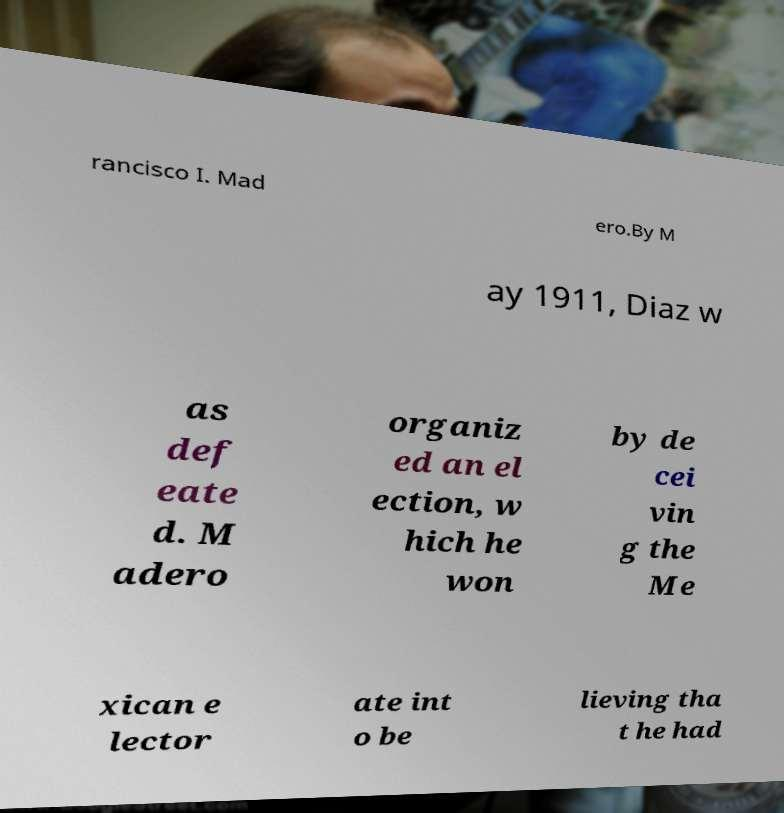What messages or text are displayed in this image? I need them in a readable, typed format. rancisco I. Mad ero.By M ay 1911, Diaz w as def eate d. M adero organiz ed an el ection, w hich he won by de cei vin g the Me xican e lector ate int o be lieving tha t he had 